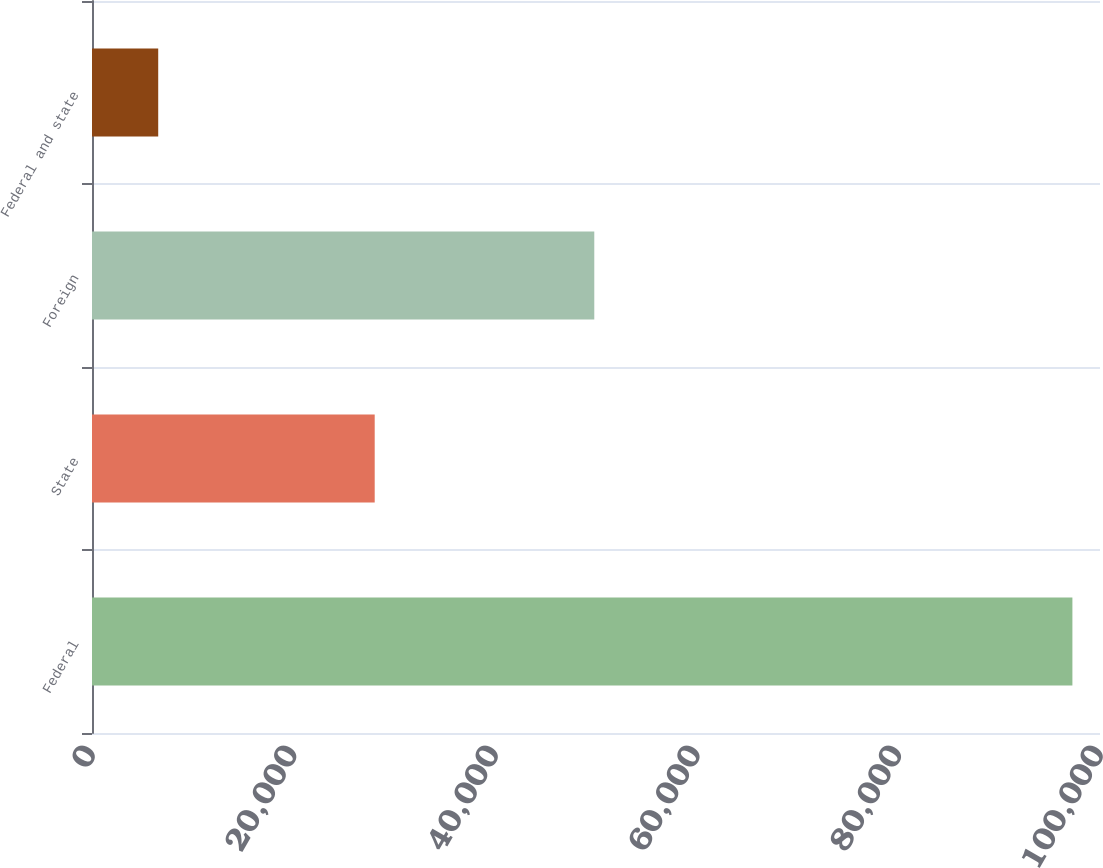<chart> <loc_0><loc_0><loc_500><loc_500><bar_chart><fcel>Federal<fcel>State<fcel>Foreign<fcel>Federal and state<nl><fcel>97262<fcel>28046<fcel>49830<fcel>6569<nl></chart> 